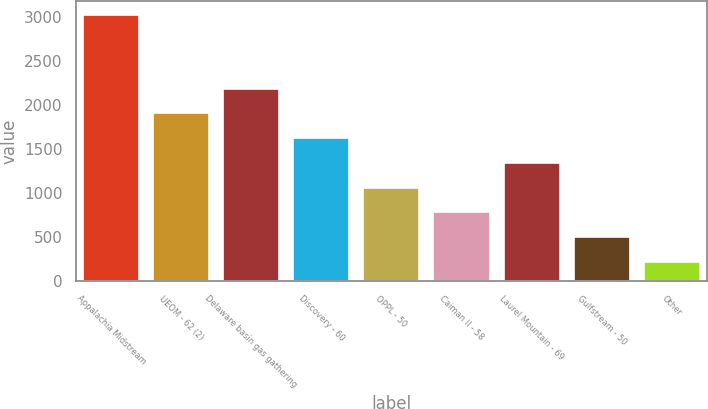Convert chart to OTSL. <chart><loc_0><loc_0><loc_500><loc_500><bar_chart><fcel>Appalachia Midstream<fcel>UEOM - 62 (2)<fcel>Delaware basin gas gathering<fcel>Discovery - 60<fcel>OPPL - 50<fcel>Caiman II - 58<fcel>Laurel Mountain - 69<fcel>Gulfstream - 50<fcel>Other<nl><fcel>3033<fcel>1905.8<fcel>2187.6<fcel>1624<fcel>1060.4<fcel>778.6<fcel>1342.2<fcel>496.8<fcel>215<nl></chart> 